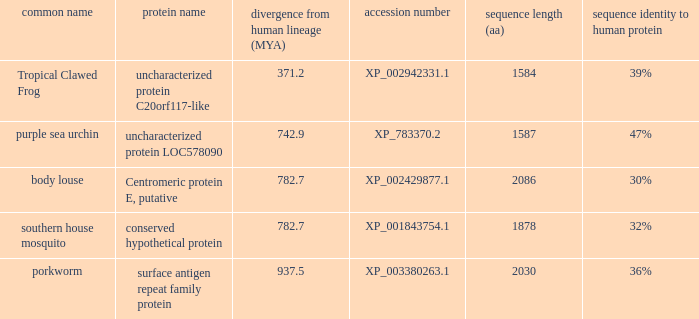I'm looking to parse the entire table for insights. Could you assist me with that? {'header': ['common name', 'protein name', 'divergence from human lineage (MYA)', 'accession number', 'sequence length (aa)', 'sequence identity to human protein'], 'rows': [['Tropical Clawed Frog', 'uncharacterized protein C20orf117-like', '371.2', 'XP_002942331.1', '1584', '39%'], ['purple sea urchin', 'uncharacterized protein LOC578090', '742.9', 'XP_783370.2', '1587', '47%'], ['body louse', 'Centromeric protein E, putative', '782.7', 'XP_002429877.1', '2086', '30%'], ['southern house mosquito', 'conserved hypothetical protein', '782.7', 'XP_001843754.1', '1878', '32%'], ['porkworm', 'surface antigen repeat family protein', '937.5', 'XP_003380263.1', '2030', '36%']]} What is the entry number of the protein with a deviation from human lineage of 93 XP_003380263.1. 